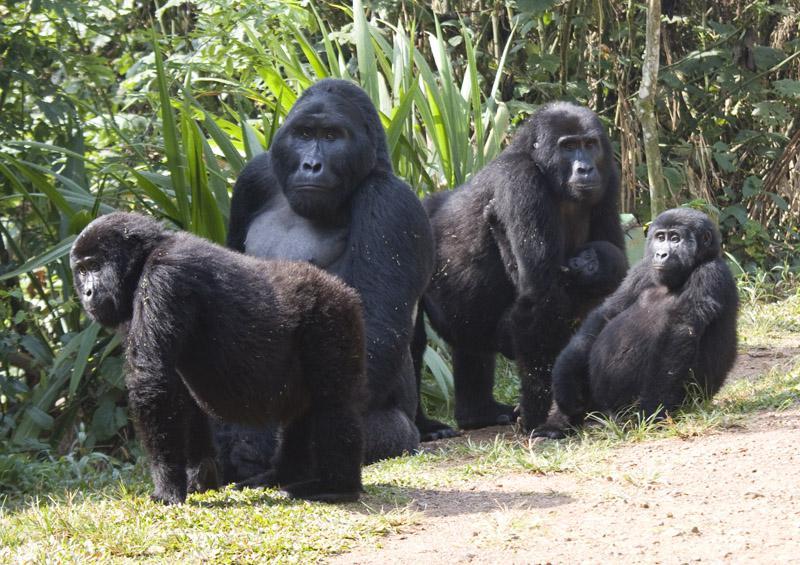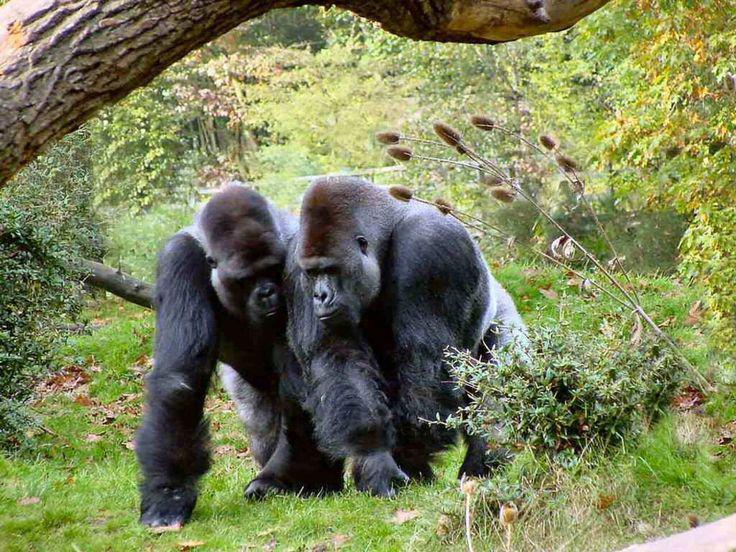The first image is the image on the left, the second image is the image on the right. For the images displayed, is the sentence "In each image, the gorilla closest to the camera is on all fours." factually correct? Answer yes or no. Yes. The first image is the image on the left, the second image is the image on the right. Evaluate the accuracy of this statement regarding the images: "The left image contains exactly four gorillas.". Is it true? Answer yes or no. Yes. 